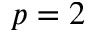Convert formula to latex. <formula><loc_0><loc_0><loc_500><loc_500>p = 2</formula> 